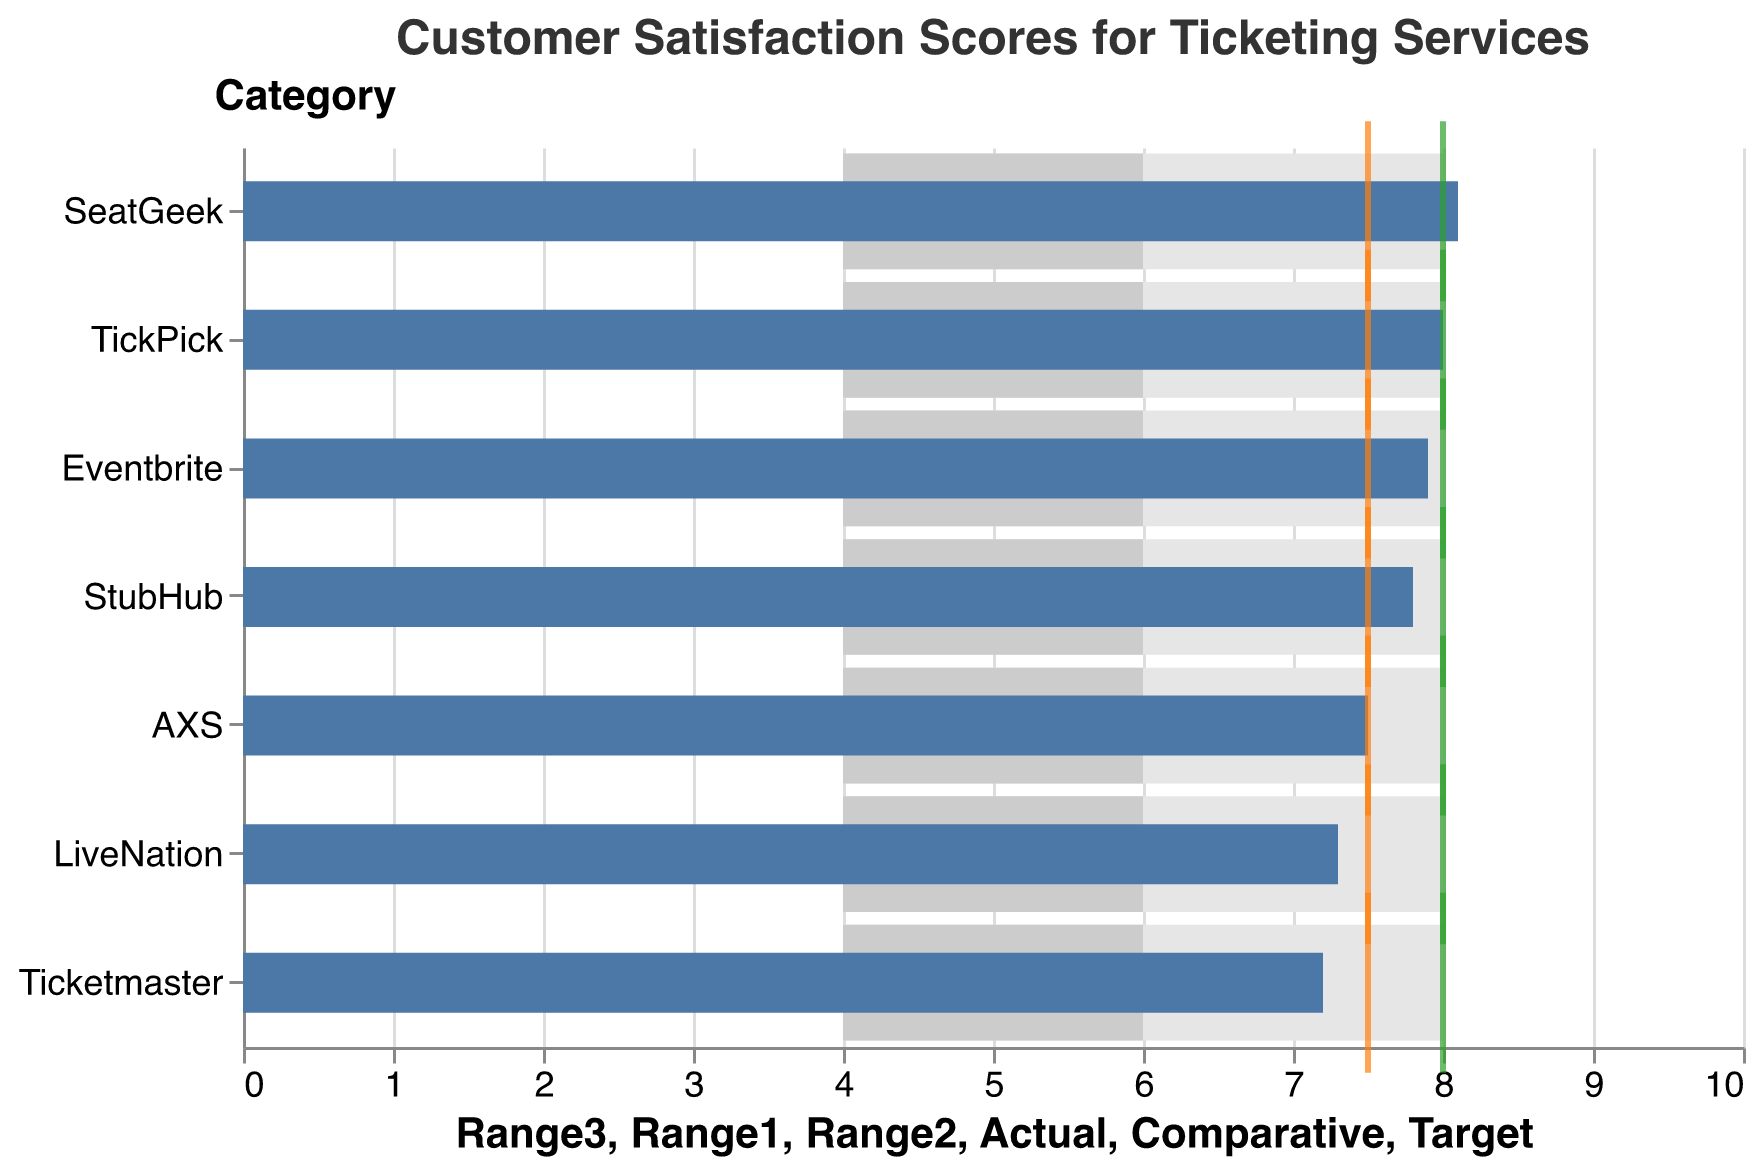What's the title of the figure? The title of the figure is typically displayed prominently at the top of the chart. In this instance, the title is indicated in the "title" attribute within the code.
Answer: Customer Satisfaction Scores for Ticketing Services How many ticketing services are displayed in the chart? The number of ticketing services corresponds to the number of unique bars or categories listed along the y-axis in the chart. By counting these categories, one can determine the total number of entities represented.
Answer: 7 Which ticketing service has the highest actual customer satisfaction score? Reviewing the values associated with the "Actual" scores for each service, find the highest numerical value. In this case, SeatGeek has the highest score.
Answer: SeatGeek How do the actual scores compare to the target score for each service? Examine the difference between each actual score and the target score for each service. All the actual scores are slightly below the target score of 8.0, with SeatGeek being closest.
Answer: All actual scores are slightly below 8.0 Which services exceeded the comparative score? Compare the "Actual" scores with the "Comparative" scores for each service. Services with an actual score higher than the comparative score will be the ones that exceeded it.
Answer: SeatGeek, Eventbrite, TickPick What is the distinction between the colored bars in the chart? The different shades of bars represent different ranges of satisfaction scores. The light gray is for scores 4.0-6.0, the medium gray is for 6.0-8.0, and the darkest bar represents scores from 4.0 to 8.0 for each ticketing service.
Answer: Different ranges of satisfaction scores How does TickPick's customer satisfaction score compare to Ticketmaster's? By comparing the "Actual" scores of both TickPick and Ticketmaster, observe that TickPick has a higher score than Ticketmaster.
Answer: TickPick's score is higher than Ticketmaster's Which ticketing service is closest to meeting its target score? Determine the differences between the actual scores and the target score (8.0) for each service. The service with the smallest difference is the closest. SeatGeek at 8.1 is the nearest to the target.
Answer: SeatGeek What is the range of the customer satisfaction scores across all services? Identify the highest and lowest actual scores in the data. The range is the difference between these two scores. SeatGeek has the highest score of 8.1, and Ticketmaster has the lowest score of 7.2.
Answer: Range is from 7.2 to 8.1 How many services have their comparative score exactly at 7.5? Count the number of entries in the data where the "Comparative" score is equal to 7.5.
Answer: 6 Which service has the lowest customer satisfaction score but has reached its comparative score? Check the "Actual" scores and identify the lowest one, then ensure that its "Actual" score is equal to its "Comparative" score.
Answer: AXS 